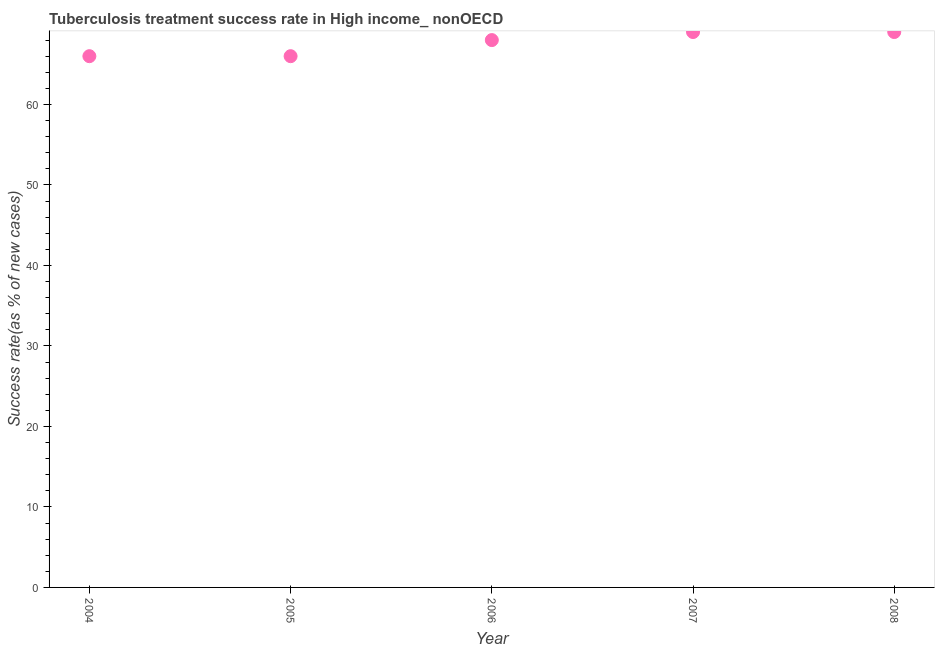What is the tuberculosis treatment success rate in 2006?
Provide a succinct answer. 68. Across all years, what is the maximum tuberculosis treatment success rate?
Offer a very short reply. 69. Across all years, what is the minimum tuberculosis treatment success rate?
Your answer should be compact. 66. In which year was the tuberculosis treatment success rate maximum?
Keep it short and to the point. 2007. What is the sum of the tuberculosis treatment success rate?
Give a very brief answer. 338. What is the difference between the tuberculosis treatment success rate in 2006 and 2007?
Your answer should be compact. -1. What is the average tuberculosis treatment success rate per year?
Keep it short and to the point. 67.6. Do a majority of the years between 2005 and 2004 (inclusive) have tuberculosis treatment success rate greater than 36 %?
Ensure brevity in your answer.  No. What is the ratio of the tuberculosis treatment success rate in 2007 to that in 2008?
Provide a short and direct response. 1. Is the tuberculosis treatment success rate in 2004 less than that in 2007?
Your response must be concise. Yes. What is the difference between the highest and the lowest tuberculosis treatment success rate?
Provide a succinct answer. 3. In how many years, is the tuberculosis treatment success rate greater than the average tuberculosis treatment success rate taken over all years?
Give a very brief answer. 3. How many years are there in the graph?
Give a very brief answer. 5. Does the graph contain any zero values?
Offer a very short reply. No. Does the graph contain grids?
Make the answer very short. No. What is the title of the graph?
Offer a terse response. Tuberculosis treatment success rate in High income_ nonOECD. What is the label or title of the X-axis?
Ensure brevity in your answer.  Year. What is the label or title of the Y-axis?
Provide a succinct answer. Success rate(as % of new cases). What is the Success rate(as % of new cases) in 2005?
Ensure brevity in your answer.  66. What is the Success rate(as % of new cases) in 2006?
Keep it short and to the point. 68. What is the Success rate(as % of new cases) in 2008?
Offer a terse response. 69. What is the difference between the Success rate(as % of new cases) in 2004 and 2005?
Your answer should be compact. 0. What is the difference between the Success rate(as % of new cases) in 2004 and 2007?
Keep it short and to the point. -3. What is the difference between the Success rate(as % of new cases) in 2005 and 2008?
Provide a short and direct response. -3. What is the difference between the Success rate(as % of new cases) in 2006 and 2007?
Offer a terse response. -1. What is the difference between the Success rate(as % of new cases) in 2006 and 2008?
Your response must be concise. -1. What is the difference between the Success rate(as % of new cases) in 2007 and 2008?
Make the answer very short. 0. What is the ratio of the Success rate(as % of new cases) in 2004 to that in 2005?
Offer a terse response. 1. What is the ratio of the Success rate(as % of new cases) in 2004 to that in 2006?
Your answer should be very brief. 0.97. What is the ratio of the Success rate(as % of new cases) in 2005 to that in 2007?
Your response must be concise. 0.96. What is the ratio of the Success rate(as % of new cases) in 2005 to that in 2008?
Make the answer very short. 0.96. What is the ratio of the Success rate(as % of new cases) in 2006 to that in 2007?
Your response must be concise. 0.99. 